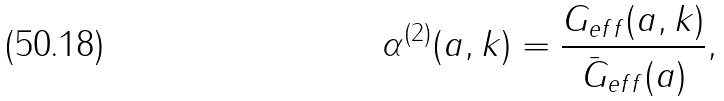<formula> <loc_0><loc_0><loc_500><loc_500>\alpha ^ { ( 2 ) } ( a , { k } ) = \frac { G _ { e f f } ( a , { k } ) } { \bar { G } _ { e f f } ( a ) } ,</formula> 